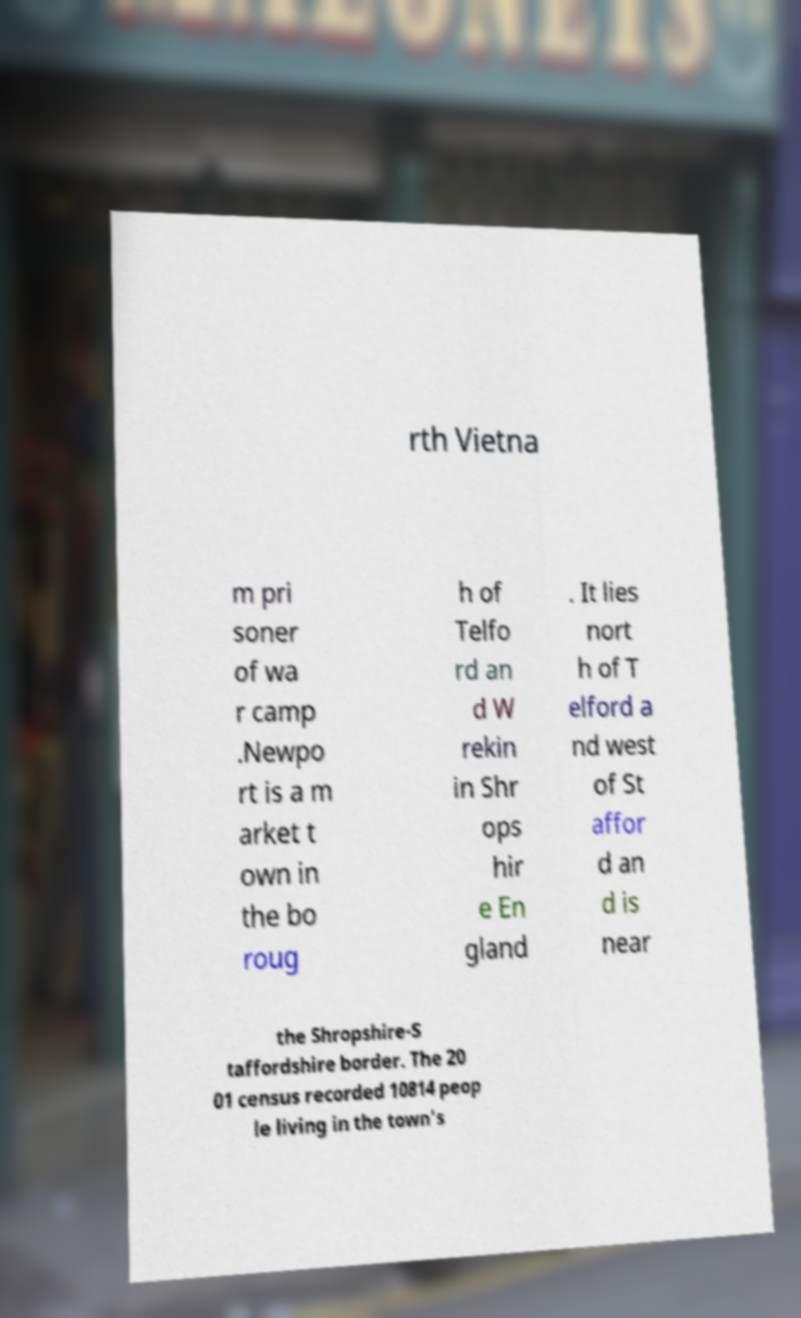For documentation purposes, I need the text within this image transcribed. Could you provide that? rth Vietna m pri soner of wa r camp .Newpo rt is a m arket t own in the bo roug h of Telfo rd an d W rekin in Shr ops hir e En gland . It lies nort h of T elford a nd west of St affor d an d is near the Shropshire-S taffordshire border. The 20 01 census recorded 10814 peop le living in the town's 